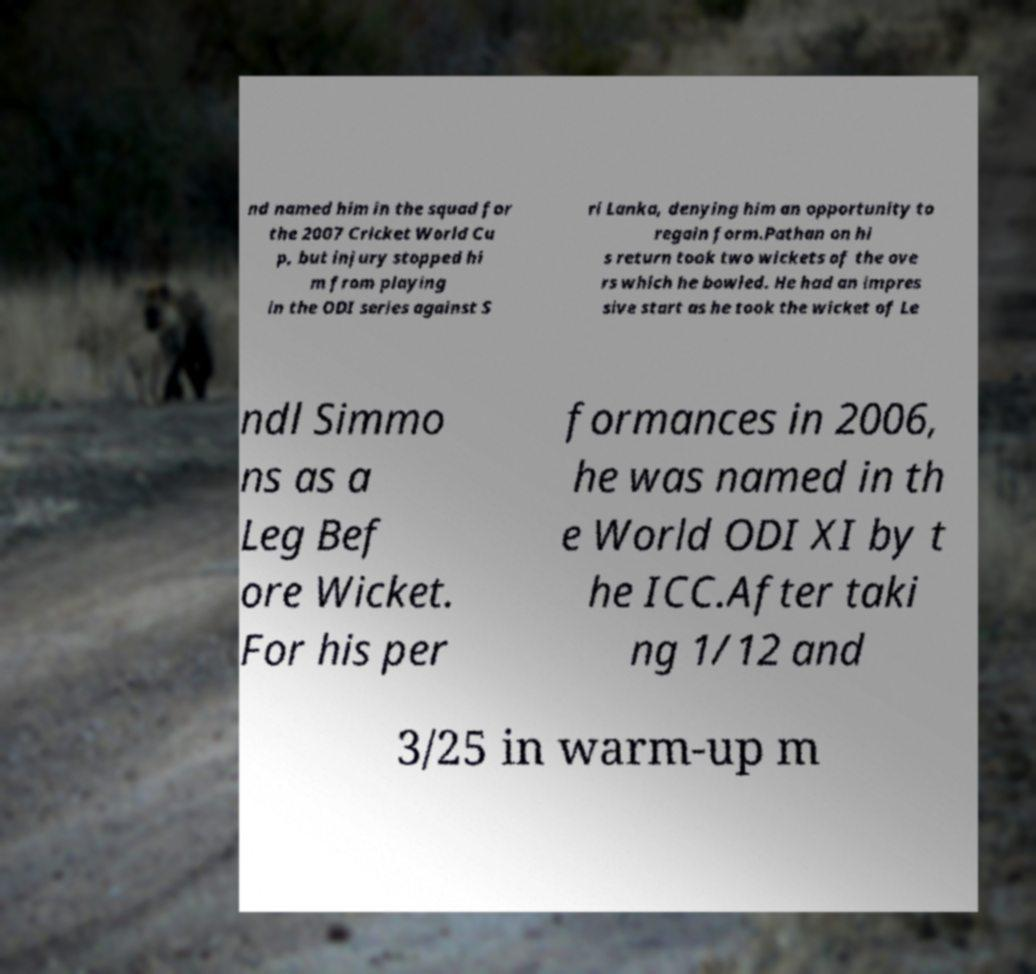What messages or text are displayed in this image? I need them in a readable, typed format. nd named him in the squad for the 2007 Cricket World Cu p, but injury stopped hi m from playing in the ODI series against S ri Lanka, denying him an opportunity to regain form.Pathan on hi s return took two wickets of the ove rs which he bowled. He had an impres sive start as he took the wicket of Le ndl Simmo ns as a Leg Bef ore Wicket. For his per formances in 2006, he was named in th e World ODI XI by t he ICC.After taki ng 1/12 and 3/25 in warm-up m 